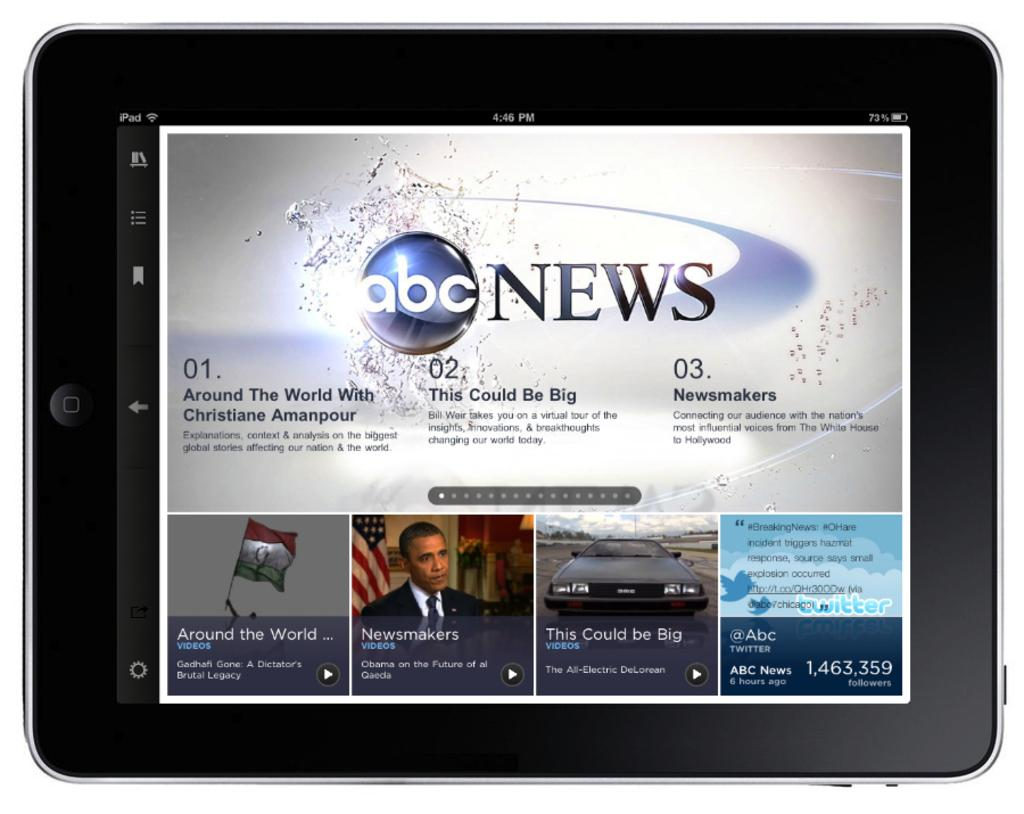What is the main subject of the image? The main subject of the image is a picture of a mobile. What else can be seen in the middle of the image? There is text in the middle of the image. Are there any other images or pictures in the image? Yes, there are pictures at the bottom of the image. What color is the orange sack in the image? There is no orange sack present in the image. 